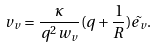Convert formula to latex. <formula><loc_0><loc_0><loc_500><loc_500>v _ { v } = \frac { \kappa } { q ^ { 2 } w _ { v } } ( q + \frac { 1 } { R } ) \tilde { e _ { v } } .</formula> 